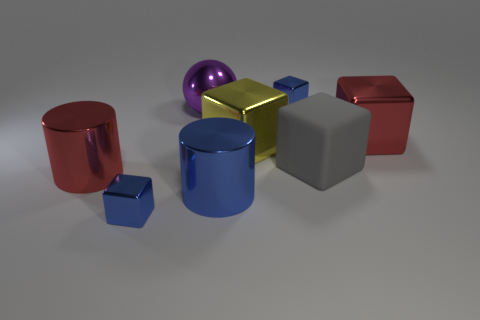What number of metal things are behind the tiny blue object that is in front of the big blue cylinder?
Make the answer very short. 6. There is a blue cylinder that is the same size as the gray thing; what material is it?
Make the answer very short. Metal. What number of other things are there of the same material as the red cylinder
Offer a terse response. 6. How many big yellow things are on the right side of the big metallic ball?
Give a very brief answer. 1. How many blocks are large yellow shiny things or metal objects?
Offer a very short reply. 4. How big is the thing that is both behind the red cube and on the right side of the large purple ball?
Provide a short and direct response. Small. How many other objects are there of the same color as the large rubber cube?
Keep it short and to the point. 0. Is the material of the red block the same as the cube that is to the left of the purple metallic thing?
Offer a very short reply. Yes. How many objects are either tiny things that are behind the yellow object or big yellow balls?
Ensure brevity in your answer.  1. There is a big metallic thing that is both left of the gray rubber block and to the right of the big blue cylinder; what shape is it?
Ensure brevity in your answer.  Cube. 